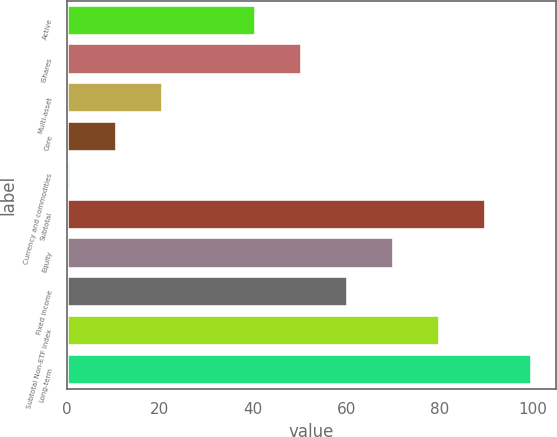Convert chart. <chart><loc_0><loc_0><loc_500><loc_500><bar_chart><fcel>Active<fcel>iShares<fcel>Multi-asset<fcel>Core<fcel>Currency and commodities<fcel>Subtotal<fcel>Equity<fcel>Fixed income<fcel>Subtotal Non-ETF Index<fcel>Long-term<nl><fcel>40.6<fcel>50.5<fcel>20.8<fcel>10.9<fcel>1<fcel>90.1<fcel>70.3<fcel>60.4<fcel>80.2<fcel>100<nl></chart> 